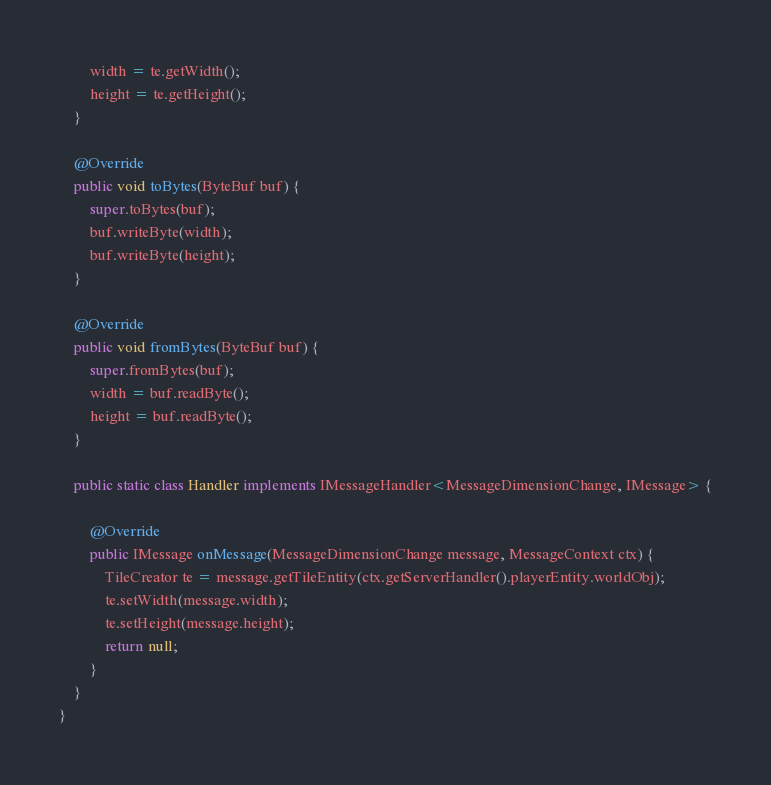Convert code to text. <code><loc_0><loc_0><loc_500><loc_500><_Java_>        width = te.getWidth();
        height = te.getHeight();
    }

    @Override
    public void toBytes(ByteBuf buf) {
        super.toBytes(buf);
        buf.writeByte(width);
        buf.writeByte(height);
    }

    @Override
    public void fromBytes(ByteBuf buf) {
        super.fromBytes(buf);
        width = buf.readByte();
        height = buf.readByte();
    }

    public static class Handler implements IMessageHandler<MessageDimensionChange, IMessage> {

        @Override
        public IMessage onMessage(MessageDimensionChange message, MessageContext ctx) {
            TileCreator te = message.getTileEntity(ctx.getServerHandler().playerEntity.worldObj);
            te.setWidth(message.width);
            te.setHeight(message.height);
            return null;
        }
    }
}
</code> 